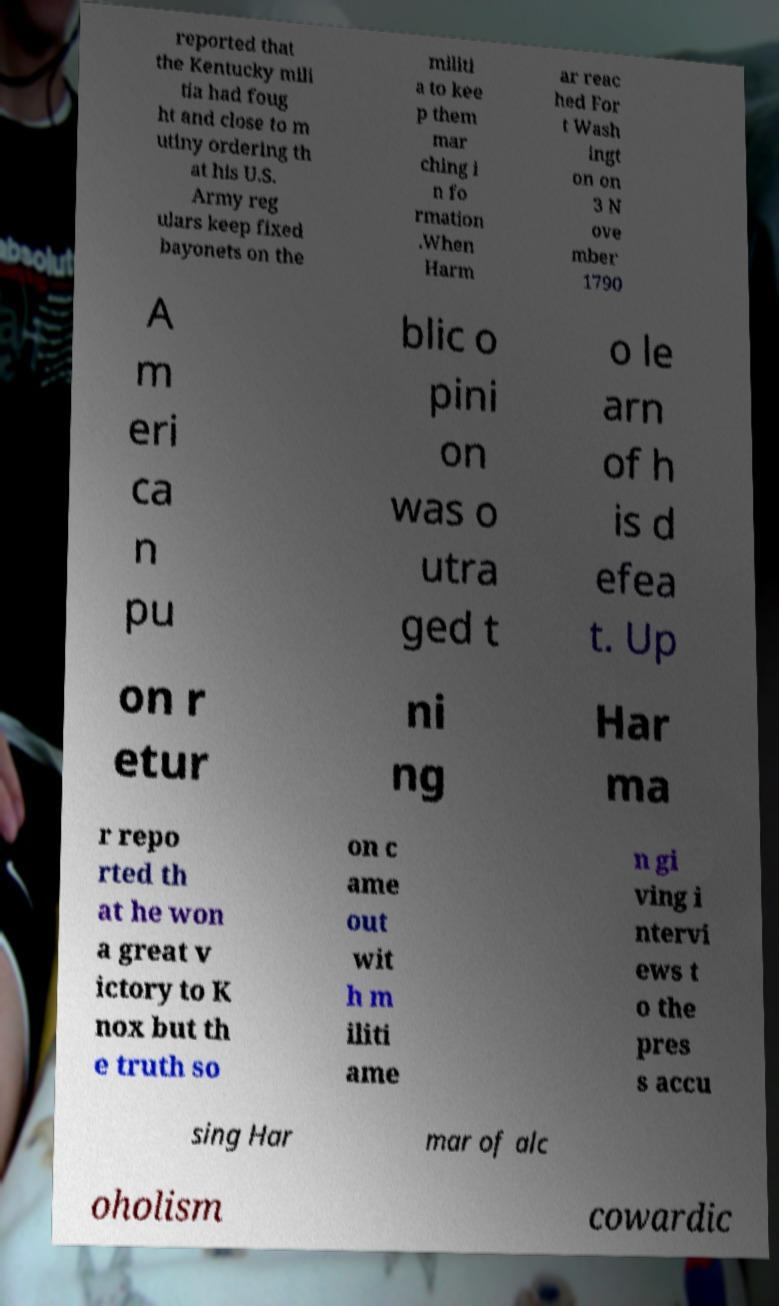Could you assist in decoding the text presented in this image and type it out clearly? reported that the Kentucky mili tia had foug ht and close to m utiny ordering th at his U.S. Army reg ulars keep fixed bayonets on the militi a to kee p them mar ching i n fo rmation .When Harm ar reac hed For t Wash ingt on on 3 N ove mber 1790 A m eri ca n pu blic o pini on was o utra ged t o le arn of h is d efea t. Up on r etur ni ng Har ma r repo rted th at he won a great v ictory to K nox but th e truth so on c ame out wit h m iliti ame n gi ving i ntervi ews t o the pres s accu sing Har mar of alc oholism cowardic 